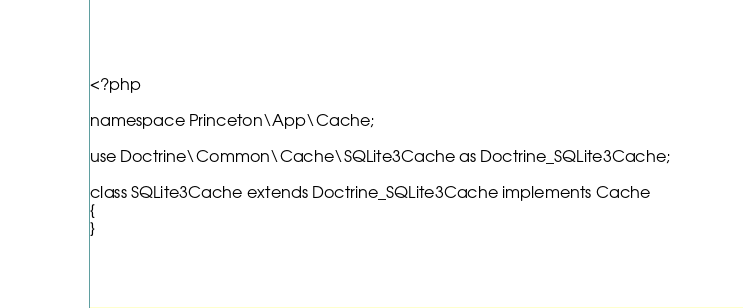Convert code to text. <code><loc_0><loc_0><loc_500><loc_500><_PHP_><?php

namespace Princeton\App\Cache;

use Doctrine\Common\Cache\SQLite3Cache as Doctrine_SQLite3Cache;

class SQLite3Cache extends Doctrine_SQLite3Cache implements Cache
{
}
</code> 